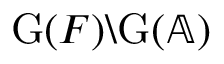Convert formula to latex. <formula><loc_0><loc_0><loc_500><loc_500>G ( F ) \ G ( \mathbb { A } )</formula> 